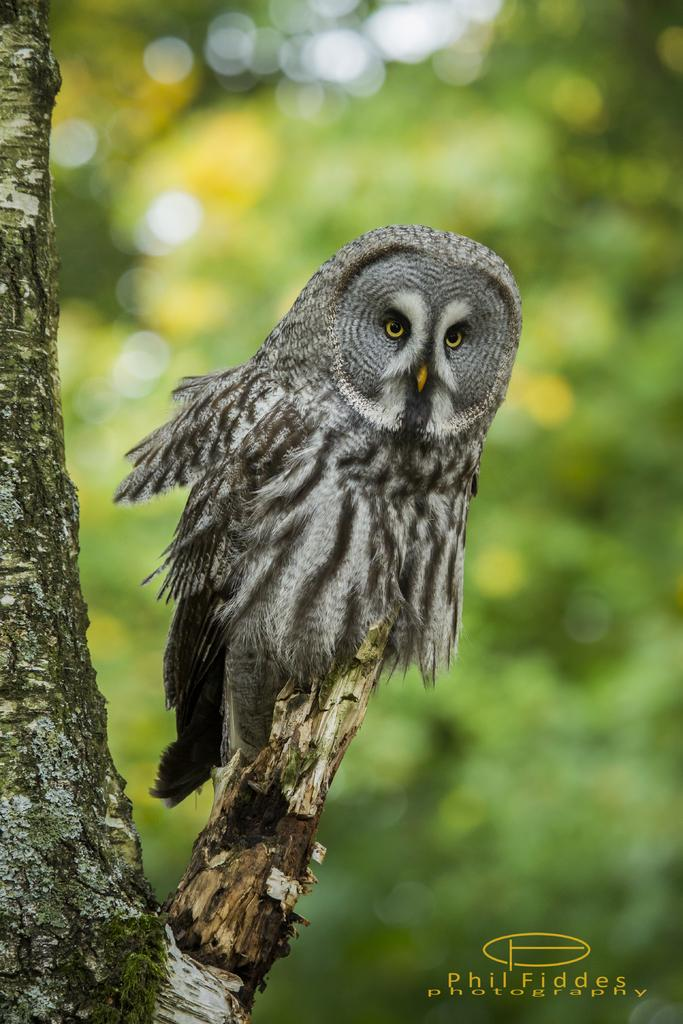What animal is the main subject of the picture? There is an owl in the picture. Can you describe the color of the owl? The owl is grey and black in color. Where is the owl located in the image? The owl is sitting on a tree branch. What can be observed about the background of the image? The background of the image is blurred. How much profit does the owl make in the image? The image does not depict any financial transactions or profits, as it is a picture of an owl sitting on a tree branch. Can you see a giraffe in the image? No, there is no giraffe present in the image; it features an owl sitting on a tree branch. 